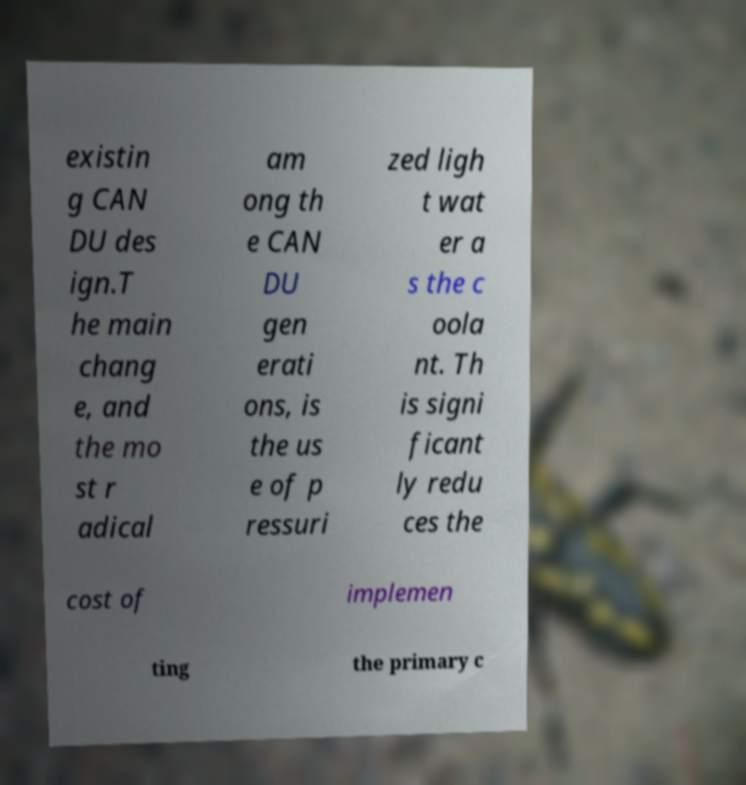Could you assist in decoding the text presented in this image and type it out clearly? existin g CAN DU des ign.T he main chang e, and the mo st r adical am ong th e CAN DU gen erati ons, is the us e of p ressuri zed ligh t wat er a s the c oola nt. Th is signi ficant ly redu ces the cost of implemen ting the primary c 